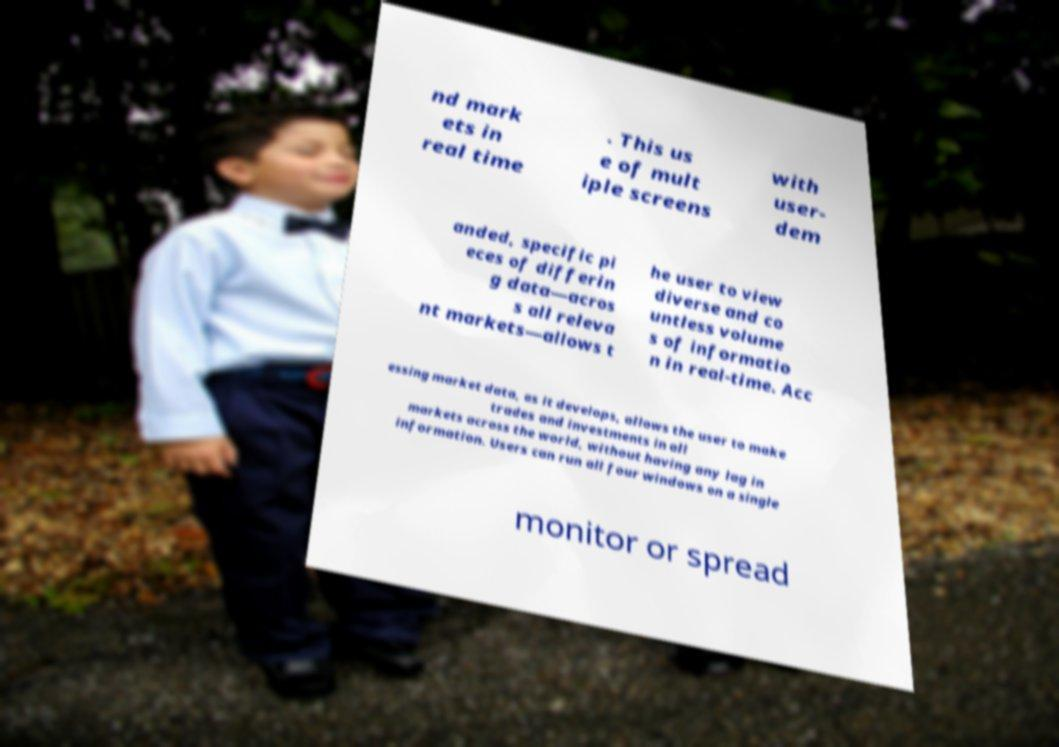What messages or text are displayed in this image? I need them in a readable, typed format. nd mark ets in real time . This us e of mult iple screens with user- dem anded, specific pi eces of differin g data—acros s all releva nt markets—allows t he user to view diverse and co untless volume s of informatio n in real-time. Acc essing market data, as it develops, allows the user to make trades and investments in all markets across the world, without having any lag in information. Users can run all four windows on a single monitor or spread 